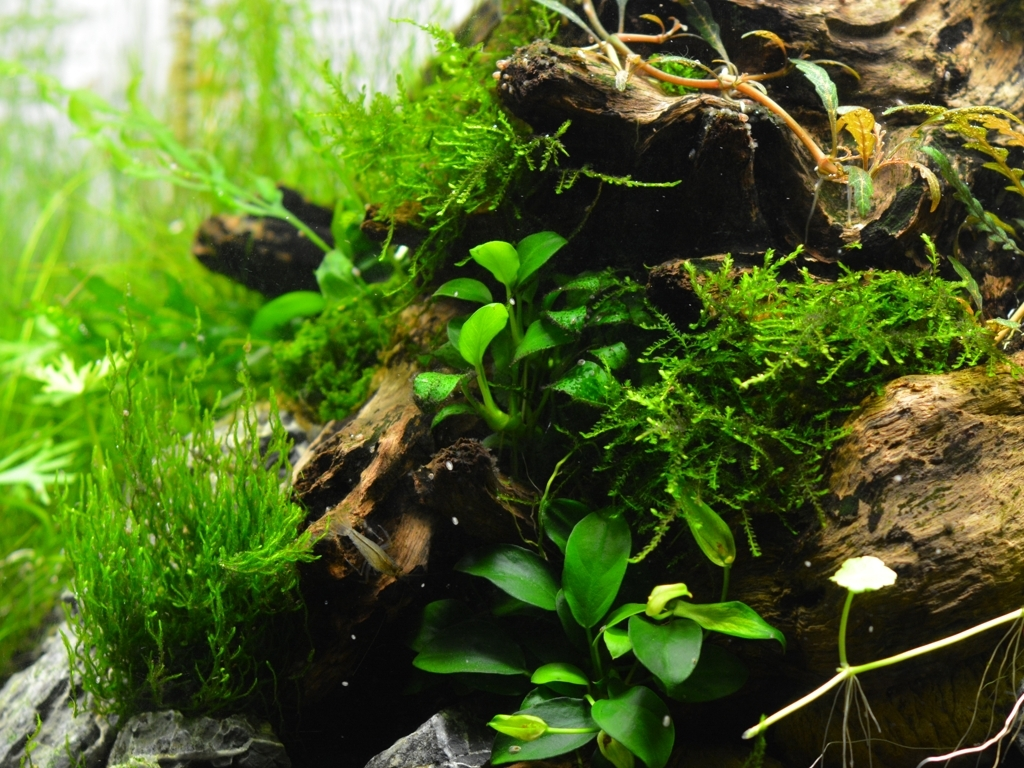Is there any wildlife present in this aquarium scene? The focus of the image is primarily on the lush vegetation and the wood used to create a natural-looking aquascape. If any wildlife such as fish or shrimp are present, they aren't immediately visible in this particular frame, possibly hiding among the flora or outside the camera's view. 